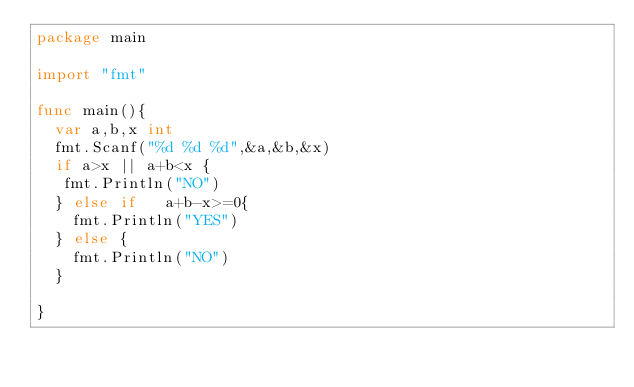Convert code to text. <code><loc_0><loc_0><loc_500><loc_500><_Go_>package main
 
import "fmt"
 
func main(){
  var a,b,x int 
  fmt.Scanf("%d %d %d",&a,&b,&x)
  if a>x || a+b<x {
   fmt.Println("NO")
  } else if   a+b-x>=0{
    fmt.Println("YES")
  } else {
    fmt.Println("NO")
  }
 
}</code> 